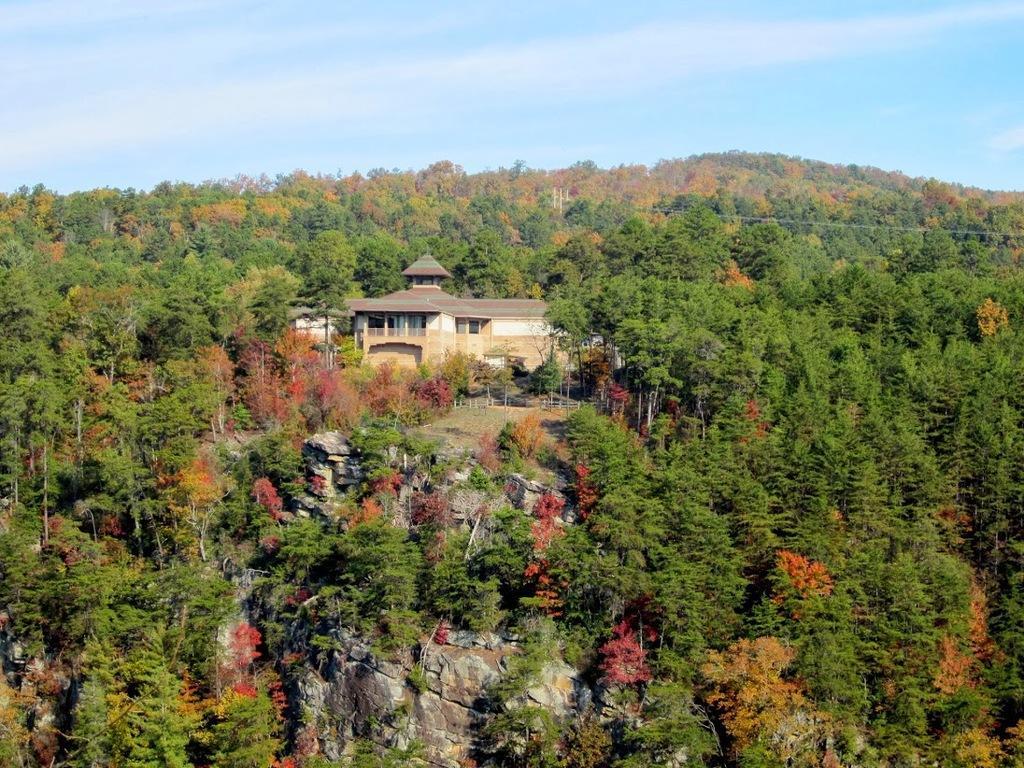How would you summarize this image in a sentence or two? In this image we can see a house, trees. At the top of the image there is sky. 